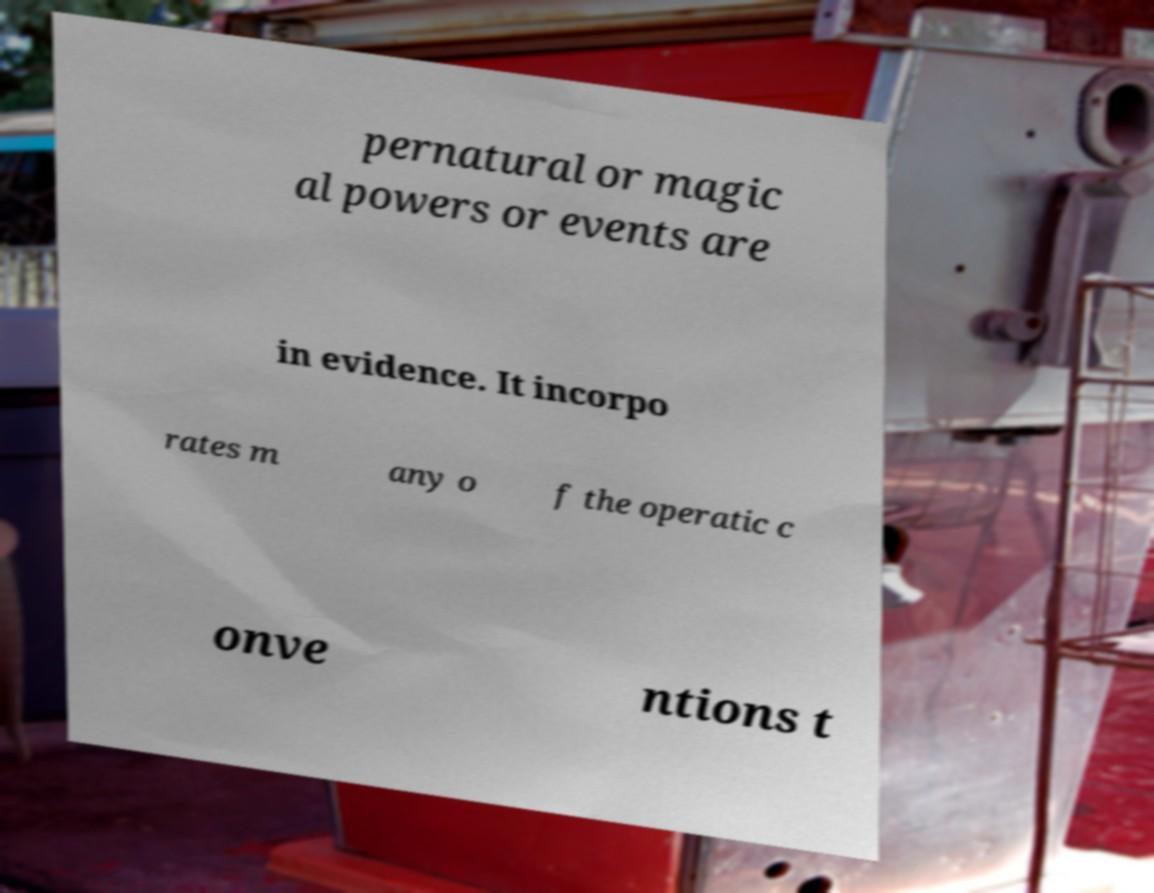I need the written content from this picture converted into text. Can you do that? pernatural or magic al powers or events are in evidence. It incorpo rates m any o f the operatic c onve ntions t 